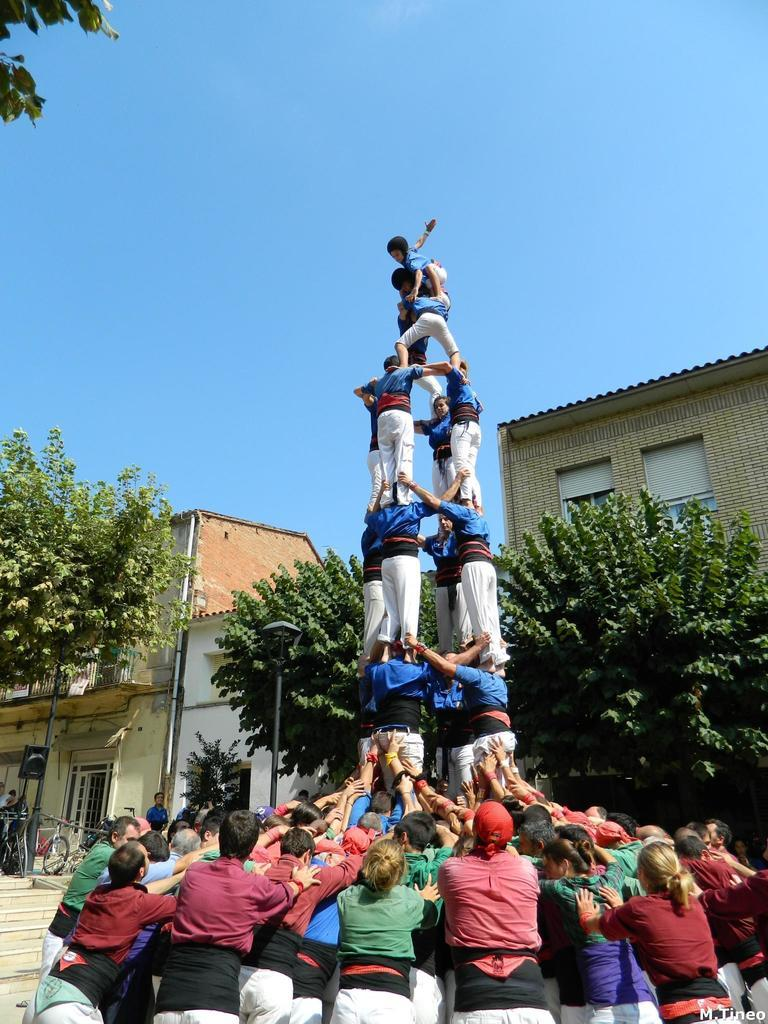How many people are in the image? There are many people in the image. How are the people arranged in the image? The people are standing in a pyramid formation. What can be seen in the background of the image? There are buildings in the background of the image. What type of vegetation is present in front of the buildings? Trees are present in front of the buildings. What is visible above the buildings? The sky is visible above the buildings. What type of note is hanging from the curtain in the image? There is no curtain or note present in the image. How does the earthquake affect the pyramid formation in the image? There is no earthquake depicted in the image, and the people are standing still in a pyramid formation. 